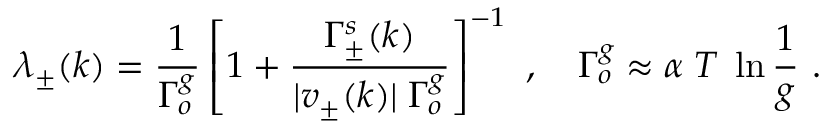Convert formula to latex. <formula><loc_0><loc_0><loc_500><loc_500>\lambda _ { \pm } ( k ) = \frac { 1 } { \Gamma _ { o } ^ { g } } \left [ 1 + \frac { \Gamma _ { \pm } ^ { s } ( k ) } { | v _ { \pm } ( k ) | \, \Gamma _ { o } ^ { g } } \right ] ^ { - 1 } , \quad \Gamma _ { o } ^ { g } \approx \alpha \, T \, \ln \frac { 1 } { g } .</formula> 